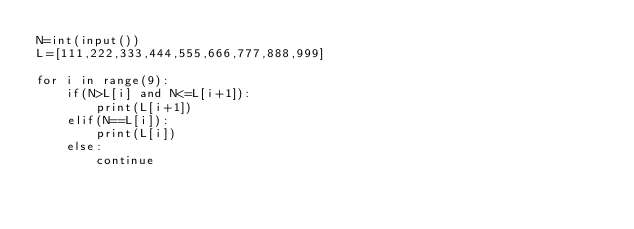<code> <loc_0><loc_0><loc_500><loc_500><_Python_>N=int(input())
L=[111,222,333,444,555,666,777,888,999]

for i in range(9):
    if(N>L[i] and N<=L[i+1]):
        print(L[i+1])
    elif(N==L[i]):
        print(L[i])
    else:
        continue
</code> 